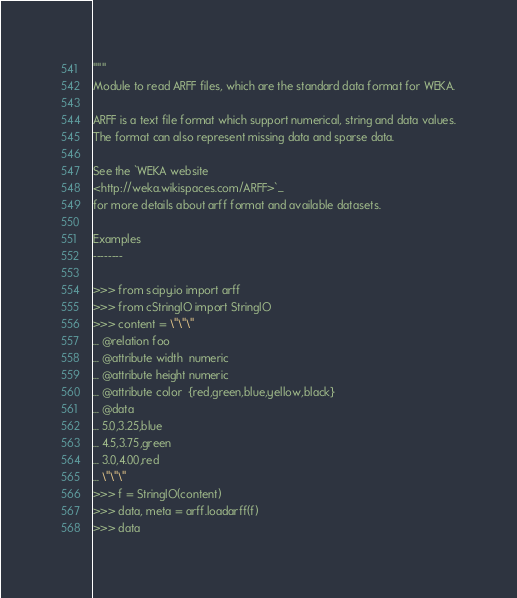Convert code to text. <code><loc_0><loc_0><loc_500><loc_500><_Python_>"""
Module to read ARFF files, which are the standard data format for WEKA.

ARFF is a text file format which support numerical, string and data values.
The format can also represent missing data and sparse data.

See the `WEKA website
<http://weka.wikispaces.com/ARFF>`_
for more details about arff format and available datasets.

Examples
--------

>>> from scipy.io import arff
>>> from cStringIO import StringIO
>>> content = \"\"\"
... @relation foo
... @attribute width  numeric
... @attribute height numeric
... @attribute color  {red,green,blue,yellow,black}
... @data
... 5.0,3.25,blue
... 4.5,3.75,green
... 3.0,4.00,red
... \"\"\"
>>> f = StringIO(content)
>>> data, meta = arff.loadarff(f)
>>> data</code> 